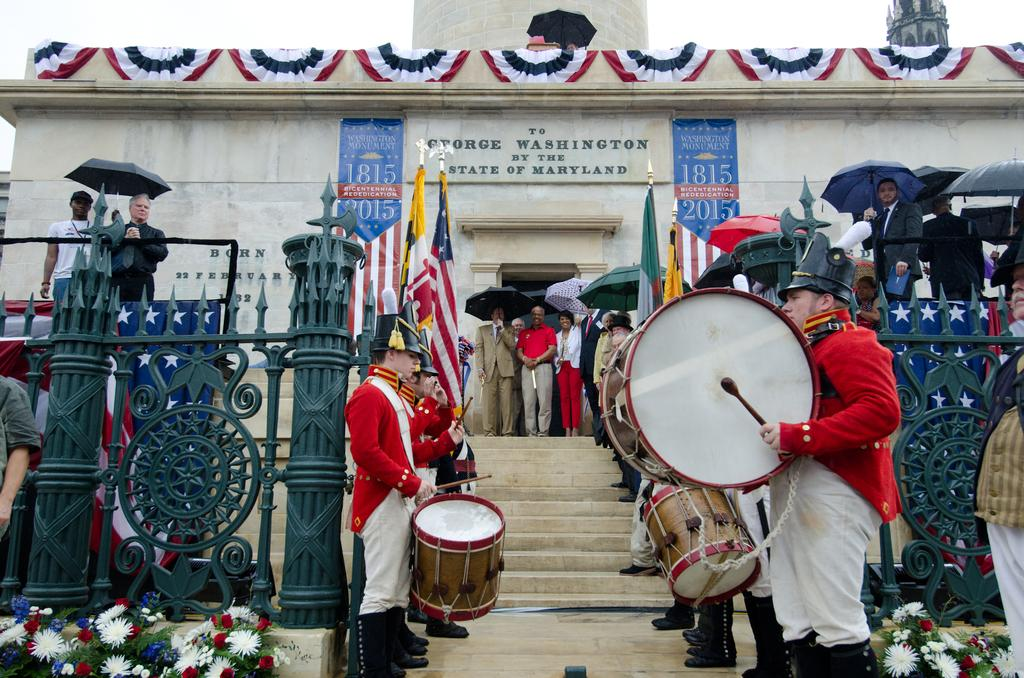What are the people in the image doing? The people in the image are playing musical instruments. Can you describe the background of the image? In the background of the image, there is a gate, a flag, and flowers. How many people are playing musical instruments in the image? The number of people playing musical instruments cannot be determined from the provided facts. What historical event is being commemorated by the people in the image? There is no indication of a historical event in the image, as it only shows people playing musical instruments and a background with a gate, flag, and flowers. 